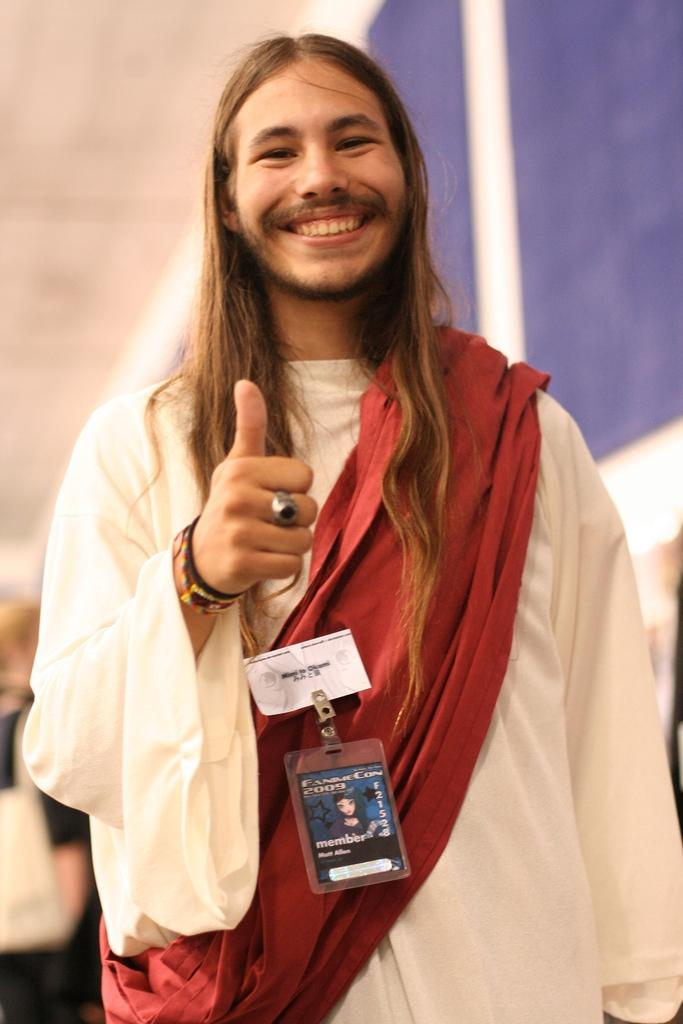What is the main subject of the image? There is a person in the image. What is the facial expression of the person in the image? The person is smiling. Can you describe the presence of another person in the image? There is another person behind the smiling person. What can be seen in the background of the image? There is a wall in the background of the image. What type of holiday is being celebrated in the image? There is no indication of a holiday being celebrated in the image. How does society react to the smiling person in the image? The image does not show any societal reaction to the smiling person. 